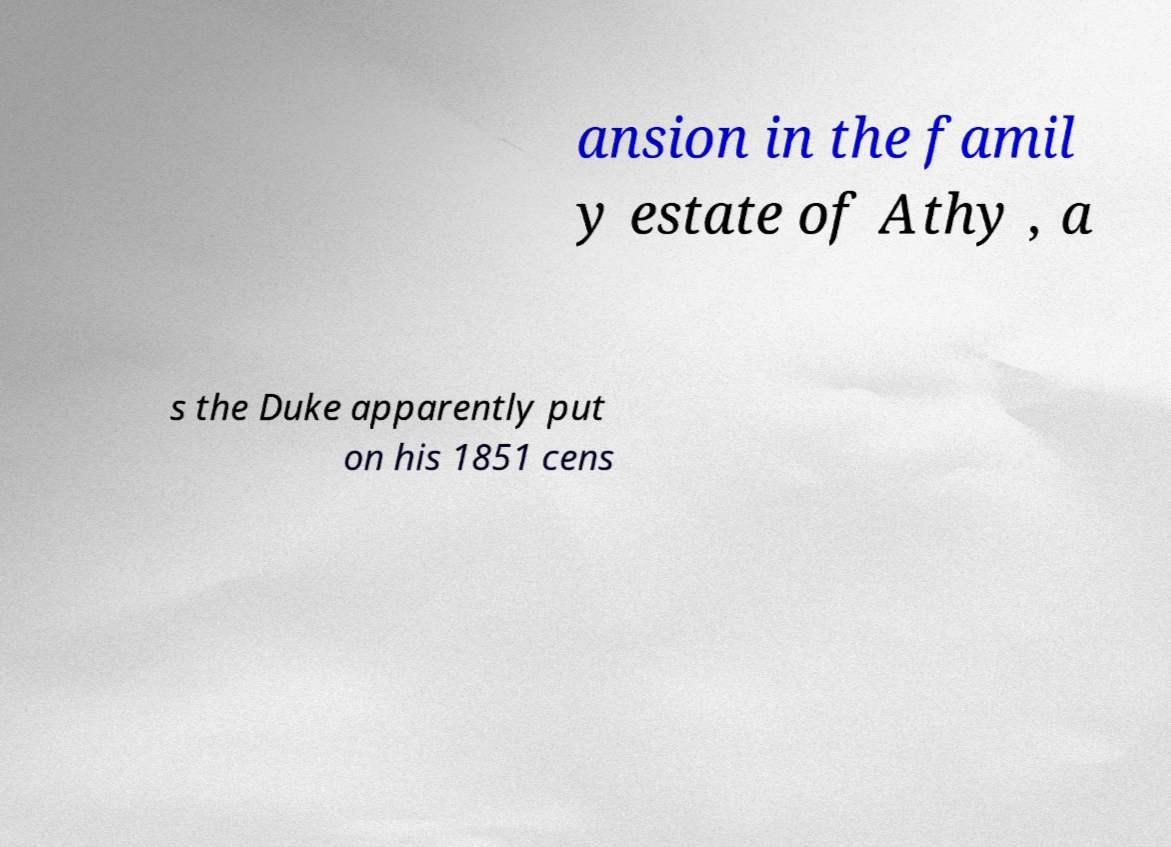What messages or text are displayed in this image? I need them in a readable, typed format. ansion in the famil y estate of Athy , a s the Duke apparently put on his 1851 cens 